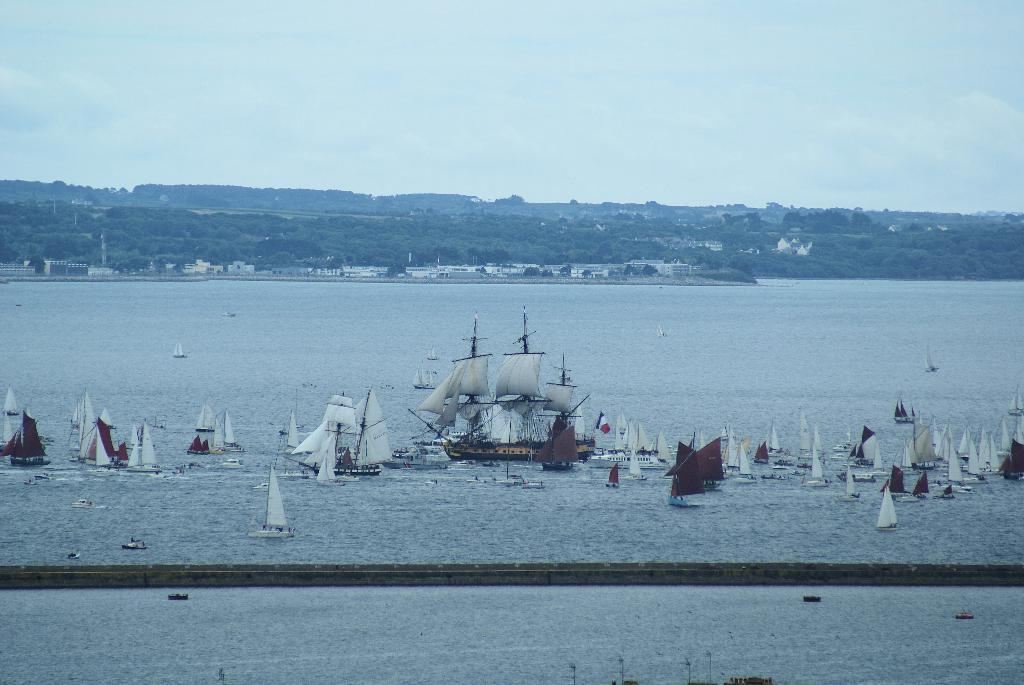What is floating on the water surface in the image? There are boats on the water surface in the image. What can be seen in the distance behind the boats? There are houses and trees visible in the background of the image. What type of ornament is hanging from the trees in the image? There are no ornaments hanging from the trees in the image; only houses, trees, and boats are present. 